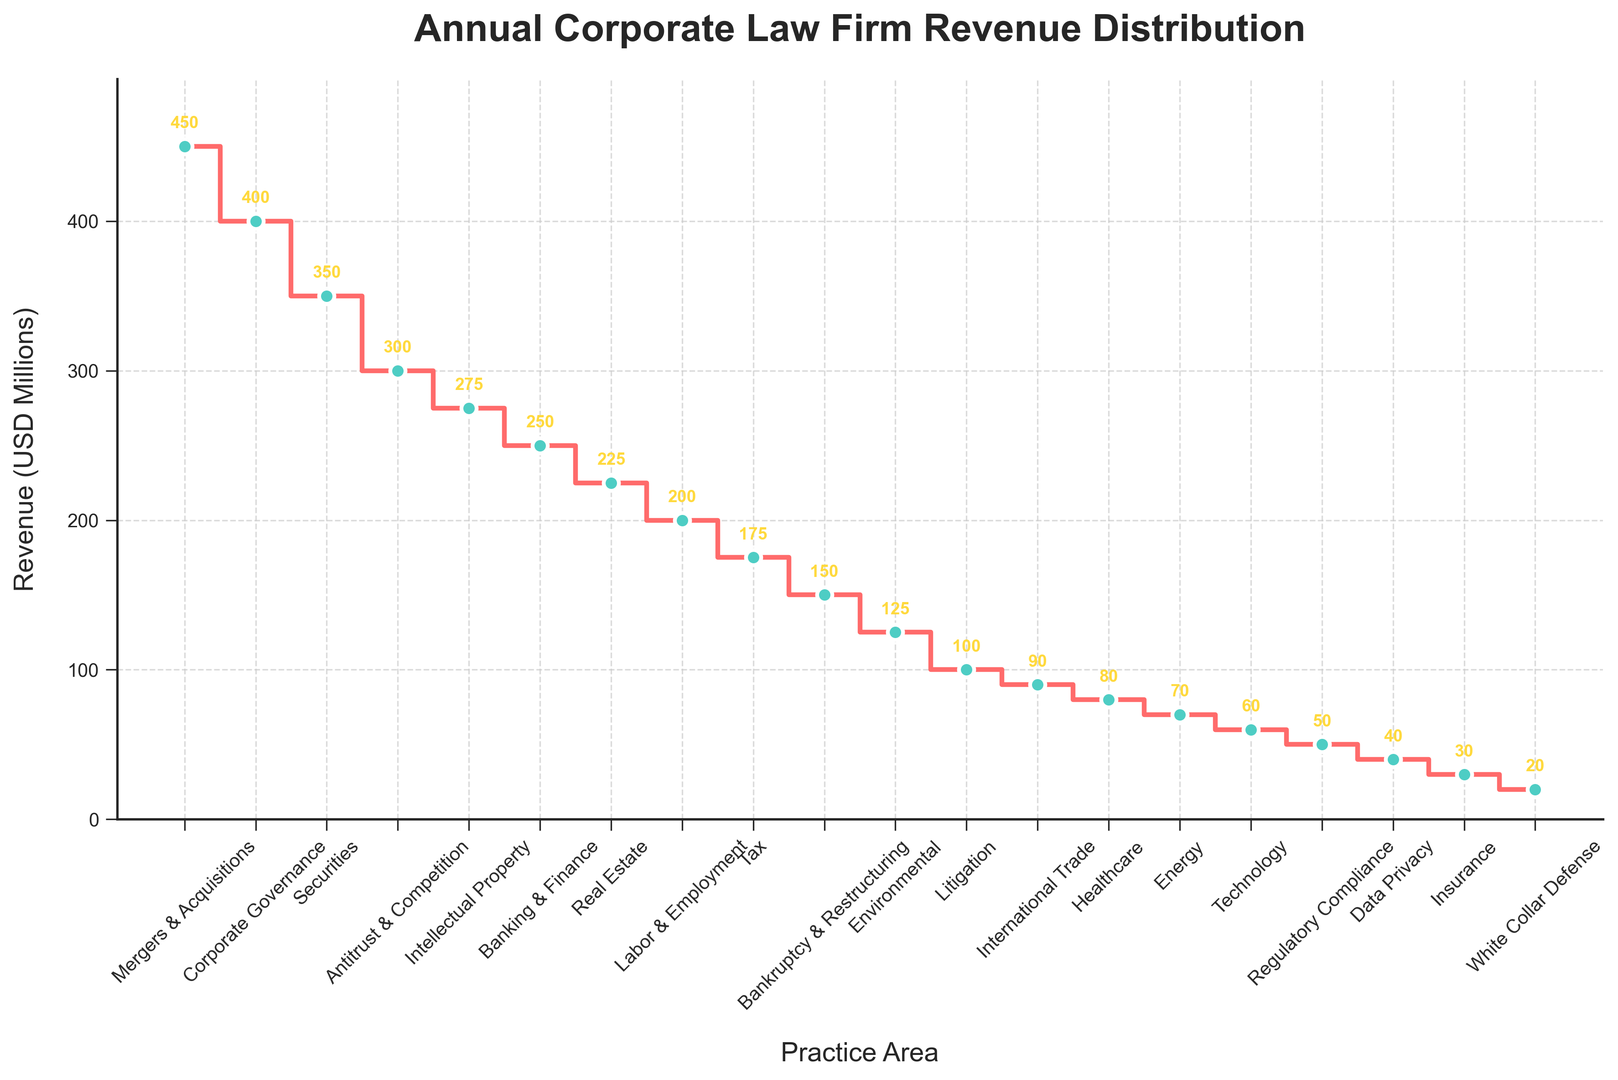What's the practice area with the highest revenue? The highest point on the plot is the first one, which corresponds to the 'Mergers & Acquisitions' practice area with a revenue of 450 USD Millions.
Answer: Mergers & Acquisitions What's the total revenue from 'Antitrust & Competition' and 'Labor & Employment'? Adding the revenues of 'Antitrust & Competition' (300 USD Millions) and 'Labor & Employment' (200 USD Millions) gives 300 + 200 = 500 USD Millions.
Answer: 500 How many practice areas have revenue equal to or greater than 300 USD Millions? From the plot, the practice areas with revenues of 300 USD Millions or greater are 'Mergers & Acquisitions', 'Corporate Governance', 'Securities', and 'Antitrust & Competition', making a total of 4.
Answer: 4 Which practice area has the lowest revenue, and what is it? The lowest point on the plot corresponds to the 'White Collar Defense' practice area with a revenue of 20 USD Millions.
Answer: White Collar Defense with 20 USD Millions What is the total revenue of all practice areas from 'Tax' to 'Insurance'? Sum the revenues: 'Tax' (175) + 'Bankruptcy & Restructuring' (150) + 'Environmental' (125) + 'Litigation' (100) + 'International Trade' (90) + 'Healthcare' (80) + 'Energy' (70) + 'Technology' (60) + 'Regulatory Compliance' (50) + 'Data Privacy' (40) + 'Insurance' (30) = 970 USD Millions.
Answer: 970 Which practice areas have revenues greater than those of 'Corporate Governance' but less than those of 'Mergers & Acquisitions'? The plot shows that only 'Corporate Governance' (400) and 'Securities' (350) have revenues between 'Corporate Governance' (400) and 'Mergers & Acquisitions' (450).
Answer: Corporate Governance, Securities What is the difference in revenue between 'Real Estate' and 'Banking & Finance'? Subtract the revenue of 'Banking & Finance' (250 USD Millions) from 'Real Estate' (225 USD Millions) to get 225 - 250 = -25 USD Millions, meaning 'Real Estate' is 25 million less than 'Banking & Finance'.
Answer: 25 less What is the average revenue of the top 5 practice areas? The sum of the revenues of 'Mergers & Acquisitions' (450), 'Corporate Governance' (400), 'Securities' (350), 'Antitrust & Competition' (300), and 'Intellectual Property' (275) is 1775 USD Millions. Dividing by 5 gives 1775 / 5 = 355 USD Millions.
Answer: 355 